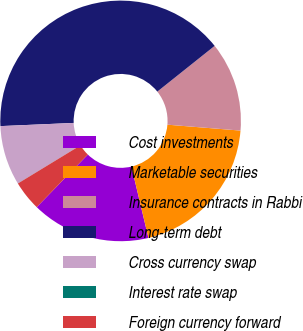<chart> <loc_0><loc_0><loc_500><loc_500><pie_chart><fcel>Cost investments<fcel>Marketable securities<fcel>Insurance contracts in Rabbi<fcel>Long-term debt<fcel>Cross currency swap<fcel>Interest rate swap<fcel>Foreign currency forward<nl><fcel>16.0%<fcel>20.0%<fcel>12.0%<fcel>39.98%<fcel>8.01%<fcel>0.01%<fcel>4.01%<nl></chart> 